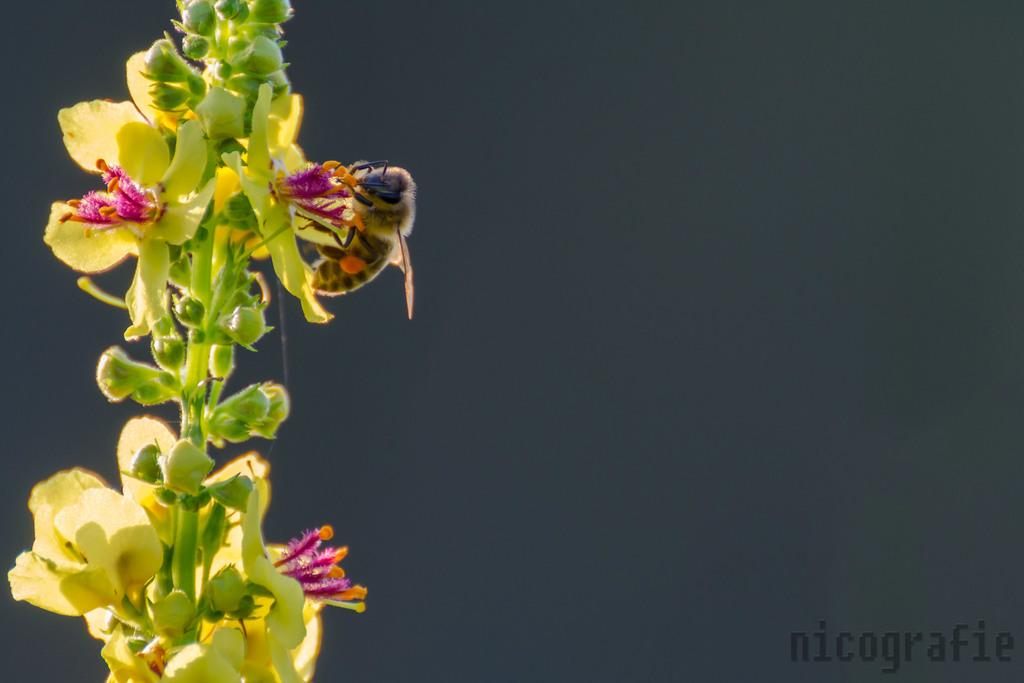What type of plants can be seen in the image? There are flowers in the image. Are there any unopened flowers in the image? Yes, there are buds in the image. Can you describe any living organisms present in the image? There is a bee on a flower in the image. What language is spoken by the flowers in the image? Flowers do not speak any language, so this question cannot be answered. 